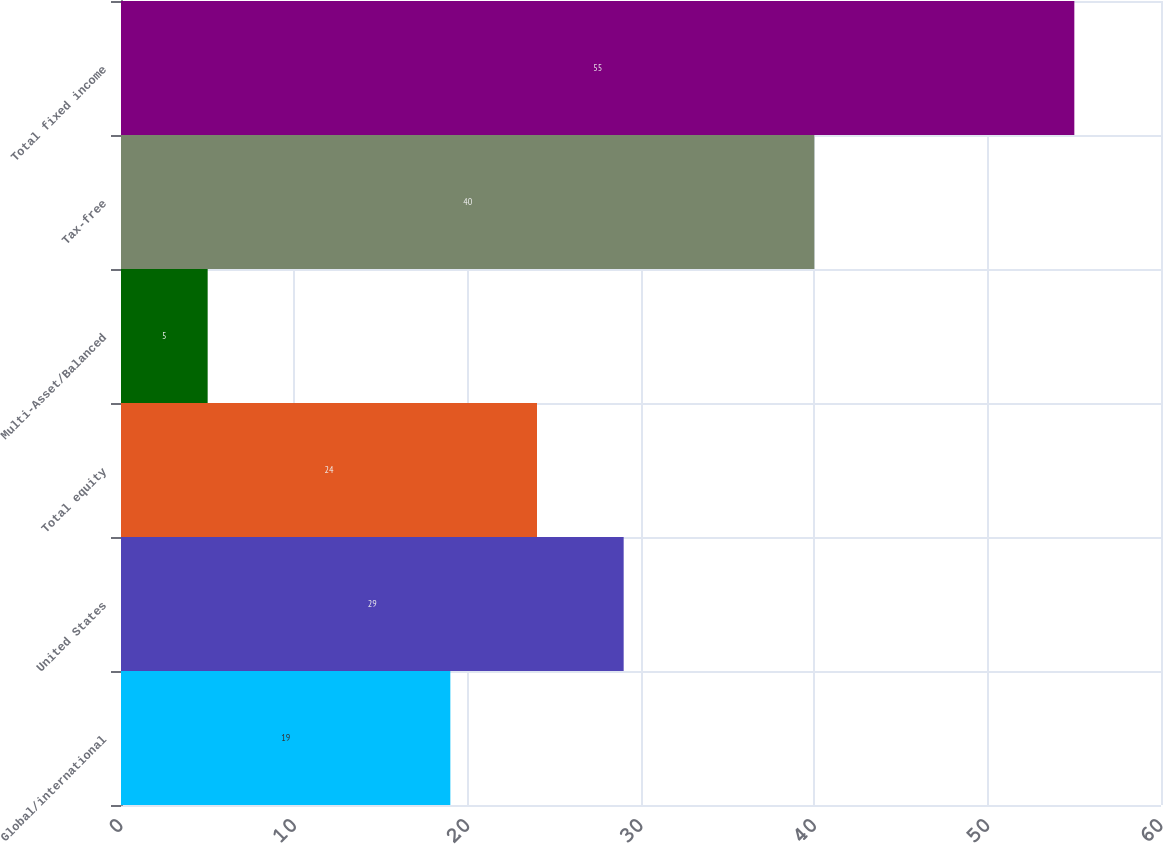Convert chart to OTSL. <chart><loc_0><loc_0><loc_500><loc_500><bar_chart><fcel>Global/international<fcel>United States<fcel>Total equity<fcel>Multi-Asset/Balanced<fcel>Tax-free<fcel>Total fixed income<nl><fcel>19<fcel>29<fcel>24<fcel>5<fcel>40<fcel>55<nl></chart> 